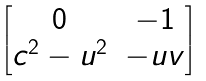<formula> <loc_0><loc_0><loc_500><loc_500>\begin{bmatrix} 0 & - 1 \\ c ^ { 2 } - u ^ { 2 } & - u v \end{bmatrix}</formula> 